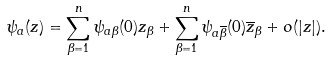<formula> <loc_0><loc_0><loc_500><loc_500>\psi _ { a } ( z ) = \sum _ { \beta = 1 } ^ { n } \psi _ { a \beta } ( 0 ) z _ { \beta } + \sum _ { \beta = 1 } ^ { n } \psi _ { a \overline { \beta } } ( 0 ) \overline { z } _ { \beta } + o ( | z | ) .</formula> 